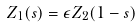Convert formula to latex. <formula><loc_0><loc_0><loc_500><loc_500>Z _ { 1 } ( s ) = \epsilon Z _ { 2 } ( 1 - s )</formula> 